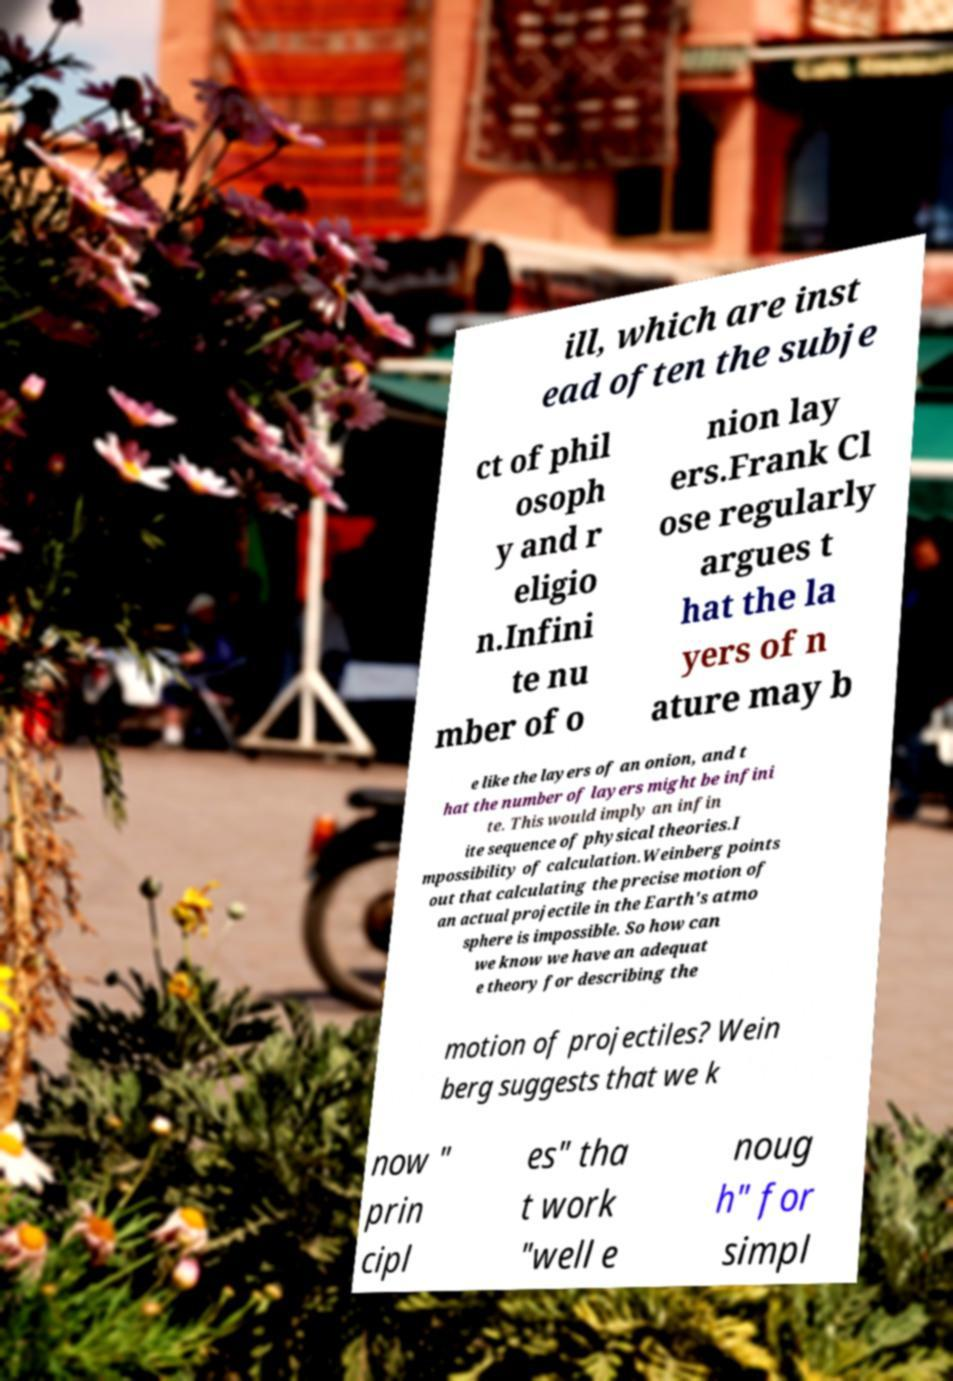Can you accurately transcribe the text from the provided image for me? ill, which are inst ead often the subje ct of phil osoph y and r eligio n.Infini te nu mber of o nion lay ers.Frank Cl ose regularly argues t hat the la yers of n ature may b e like the layers of an onion, and t hat the number of layers might be infini te. This would imply an infin ite sequence of physical theories.I mpossibility of calculation.Weinberg points out that calculating the precise motion of an actual projectile in the Earth's atmo sphere is impossible. So how can we know we have an adequat e theory for describing the motion of projectiles? Wein berg suggests that we k now " prin cipl es" tha t work "well e noug h" for simpl 